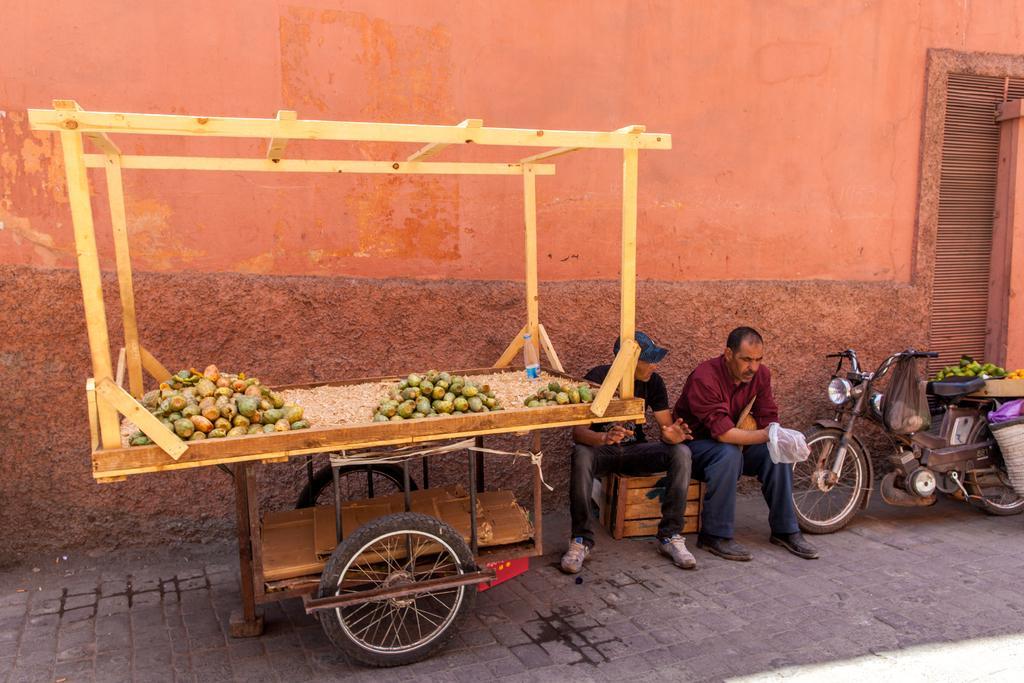Can you describe this image briefly? In this picture I can see there is a wooden trolley and there are fruits placed and there is a motorcycle at right side and there is a wall in the backdrop. 